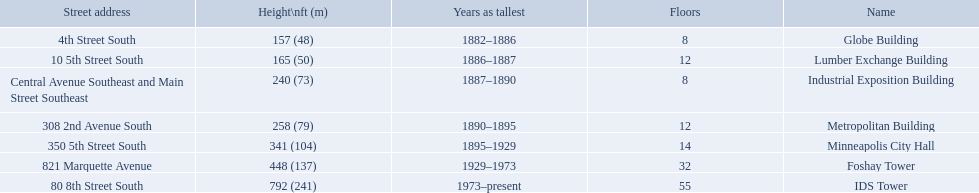What are the tallest buildings in minneapolis? Globe Building, Lumber Exchange Building, Industrial Exposition Building, Metropolitan Building, Minneapolis City Hall, Foshay Tower, IDS Tower. Which of those have 8 floors? Globe Building, Industrial Exposition Building. Of those, which is 240 ft tall? Industrial Exposition Building. How many floors does the lumber exchange building have? 12. What other building has 12 floors? Metropolitan Building. 